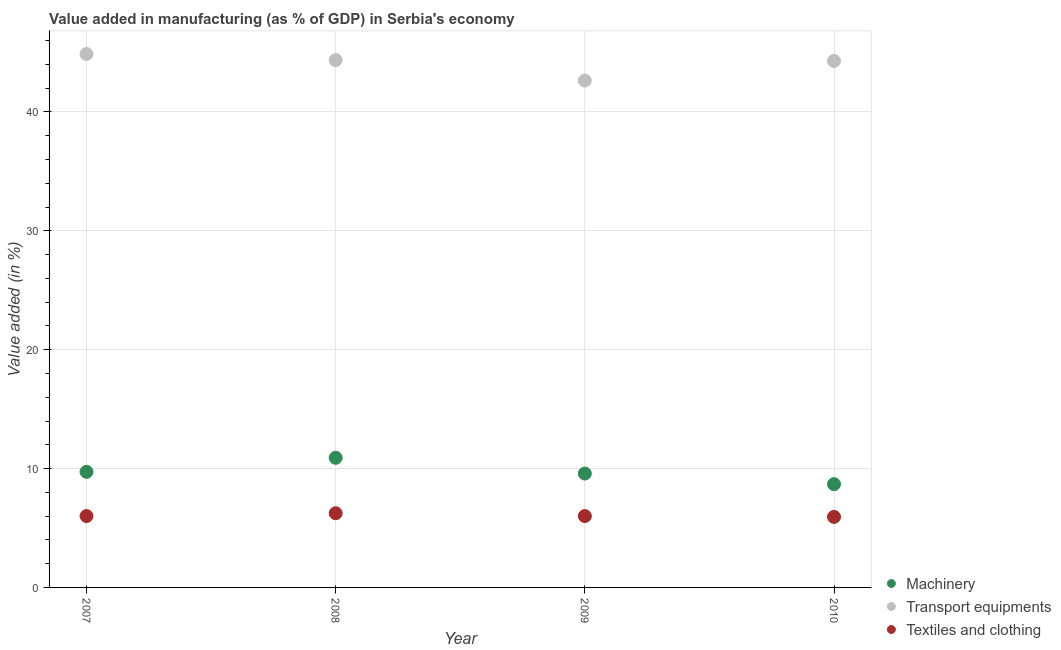How many different coloured dotlines are there?
Make the answer very short. 3. What is the value added in manufacturing machinery in 2010?
Your response must be concise. 8.69. Across all years, what is the maximum value added in manufacturing textile and clothing?
Your response must be concise. 6.24. Across all years, what is the minimum value added in manufacturing textile and clothing?
Ensure brevity in your answer.  5.94. In which year was the value added in manufacturing machinery maximum?
Ensure brevity in your answer.  2008. What is the total value added in manufacturing textile and clothing in the graph?
Your response must be concise. 24.19. What is the difference between the value added in manufacturing machinery in 2008 and that in 2009?
Your answer should be very brief. 1.33. What is the difference between the value added in manufacturing machinery in 2007 and the value added in manufacturing transport equipments in 2010?
Keep it short and to the point. -34.57. What is the average value added in manufacturing textile and clothing per year?
Ensure brevity in your answer.  6.05. In the year 2010, what is the difference between the value added in manufacturing transport equipments and value added in manufacturing machinery?
Your answer should be very brief. 35.61. In how many years, is the value added in manufacturing textile and clothing greater than 44 %?
Provide a succinct answer. 0. What is the ratio of the value added in manufacturing machinery in 2007 to that in 2009?
Ensure brevity in your answer.  1.02. Is the value added in manufacturing textile and clothing in 2007 less than that in 2008?
Ensure brevity in your answer.  Yes. Is the difference between the value added in manufacturing machinery in 2008 and 2010 greater than the difference between the value added in manufacturing textile and clothing in 2008 and 2010?
Offer a terse response. Yes. What is the difference between the highest and the second highest value added in manufacturing textile and clothing?
Offer a terse response. 0.24. What is the difference between the highest and the lowest value added in manufacturing textile and clothing?
Your response must be concise. 0.31. Is the sum of the value added in manufacturing machinery in 2007 and 2010 greater than the maximum value added in manufacturing textile and clothing across all years?
Your response must be concise. Yes. Does the value added in manufacturing transport equipments monotonically increase over the years?
Offer a very short reply. No. How many years are there in the graph?
Give a very brief answer. 4. What is the difference between two consecutive major ticks on the Y-axis?
Offer a terse response. 10. Are the values on the major ticks of Y-axis written in scientific E-notation?
Your answer should be compact. No. Does the graph contain any zero values?
Provide a succinct answer. No. Does the graph contain grids?
Your response must be concise. Yes. Where does the legend appear in the graph?
Ensure brevity in your answer.  Bottom right. What is the title of the graph?
Your response must be concise. Value added in manufacturing (as % of GDP) in Serbia's economy. What is the label or title of the X-axis?
Offer a terse response. Year. What is the label or title of the Y-axis?
Your response must be concise. Value added (in %). What is the Value added (in %) in Machinery in 2007?
Provide a succinct answer. 9.72. What is the Value added (in %) in Transport equipments in 2007?
Offer a very short reply. 44.88. What is the Value added (in %) of Textiles and clothing in 2007?
Ensure brevity in your answer.  6.01. What is the Value added (in %) in Machinery in 2008?
Make the answer very short. 10.91. What is the Value added (in %) in Transport equipments in 2008?
Your answer should be compact. 44.37. What is the Value added (in %) of Textiles and clothing in 2008?
Keep it short and to the point. 6.24. What is the Value added (in %) of Machinery in 2009?
Offer a very short reply. 9.58. What is the Value added (in %) in Transport equipments in 2009?
Your answer should be compact. 42.64. What is the Value added (in %) in Textiles and clothing in 2009?
Provide a short and direct response. 6. What is the Value added (in %) of Machinery in 2010?
Give a very brief answer. 8.69. What is the Value added (in %) in Transport equipments in 2010?
Provide a succinct answer. 44.29. What is the Value added (in %) of Textiles and clothing in 2010?
Offer a very short reply. 5.94. Across all years, what is the maximum Value added (in %) of Machinery?
Ensure brevity in your answer.  10.91. Across all years, what is the maximum Value added (in %) of Transport equipments?
Make the answer very short. 44.88. Across all years, what is the maximum Value added (in %) of Textiles and clothing?
Keep it short and to the point. 6.24. Across all years, what is the minimum Value added (in %) of Machinery?
Your answer should be very brief. 8.69. Across all years, what is the minimum Value added (in %) in Transport equipments?
Keep it short and to the point. 42.64. Across all years, what is the minimum Value added (in %) in Textiles and clothing?
Ensure brevity in your answer.  5.94. What is the total Value added (in %) of Machinery in the graph?
Your answer should be compact. 38.9. What is the total Value added (in %) in Transport equipments in the graph?
Provide a succinct answer. 176.18. What is the total Value added (in %) of Textiles and clothing in the graph?
Provide a succinct answer. 24.19. What is the difference between the Value added (in %) of Machinery in 2007 and that in 2008?
Give a very brief answer. -1.18. What is the difference between the Value added (in %) in Transport equipments in 2007 and that in 2008?
Offer a very short reply. 0.51. What is the difference between the Value added (in %) of Textiles and clothing in 2007 and that in 2008?
Give a very brief answer. -0.24. What is the difference between the Value added (in %) in Machinery in 2007 and that in 2009?
Offer a terse response. 0.14. What is the difference between the Value added (in %) in Transport equipments in 2007 and that in 2009?
Ensure brevity in your answer.  2.24. What is the difference between the Value added (in %) in Textiles and clothing in 2007 and that in 2009?
Provide a succinct answer. 0. What is the difference between the Value added (in %) in Machinery in 2007 and that in 2010?
Make the answer very short. 1.04. What is the difference between the Value added (in %) of Transport equipments in 2007 and that in 2010?
Keep it short and to the point. 0.59. What is the difference between the Value added (in %) of Textiles and clothing in 2007 and that in 2010?
Make the answer very short. 0.07. What is the difference between the Value added (in %) in Machinery in 2008 and that in 2009?
Provide a short and direct response. 1.33. What is the difference between the Value added (in %) of Transport equipments in 2008 and that in 2009?
Give a very brief answer. 1.73. What is the difference between the Value added (in %) of Textiles and clothing in 2008 and that in 2009?
Provide a succinct answer. 0.24. What is the difference between the Value added (in %) in Machinery in 2008 and that in 2010?
Make the answer very short. 2.22. What is the difference between the Value added (in %) in Transport equipments in 2008 and that in 2010?
Offer a very short reply. 0.07. What is the difference between the Value added (in %) in Textiles and clothing in 2008 and that in 2010?
Your answer should be very brief. 0.31. What is the difference between the Value added (in %) in Machinery in 2009 and that in 2010?
Provide a succinct answer. 0.89. What is the difference between the Value added (in %) of Transport equipments in 2009 and that in 2010?
Give a very brief answer. -1.66. What is the difference between the Value added (in %) in Textiles and clothing in 2009 and that in 2010?
Your answer should be very brief. 0.07. What is the difference between the Value added (in %) in Machinery in 2007 and the Value added (in %) in Transport equipments in 2008?
Keep it short and to the point. -34.64. What is the difference between the Value added (in %) in Machinery in 2007 and the Value added (in %) in Textiles and clothing in 2008?
Your response must be concise. 3.48. What is the difference between the Value added (in %) of Transport equipments in 2007 and the Value added (in %) of Textiles and clothing in 2008?
Your answer should be compact. 38.64. What is the difference between the Value added (in %) of Machinery in 2007 and the Value added (in %) of Transport equipments in 2009?
Your answer should be compact. -32.92. What is the difference between the Value added (in %) in Machinery in 2007 and the Value added (in %) in Textiles and clothing in 2009?
Provide a short and direct response. 3.72. What is the difference between the Value added (in %) of Transport equipments in 2007 and the Value added (in %) of Textiles and clothing in 2009?
Make the answer very short. 38.88. What is the difference between the Value added (in %) in Machinery in 2007 and the Value added (in %) in Transport equipments in 2010?
Give a very brief answer. -34.57. What is the difference between the Value added (in %) of Machinery in 2007 and the Value added (in %) of Textiles and clothing in 2010?
Keep it short and to the point. 3.79. What is the difference between the Value added (in %) of Transport equipments in 2007 and the Value added (in %) of Textiles and clothing in 2010?
Give a very brief answer. 38.94. What is the difference between the Value added (in %) in Machinery in 2008 and the Value added (in %) in Transport equipments in 2009?
Provide a succinct answer. -31.73. What is the difference between the Value added (in %) of Machinery in 2008 and the Value added (in %) of Textiles and clothing in 2009?
Ensure brevity in your answer.  4.9. What is the difference between the Value added (in %) of Transport equipments in 2008 and the Value added (in %) of Textiles and clothing in 2009?
Your response must be concise. 38.36. What is the difference between the Value added (in %) of Machinery in 2008 and the Value added (in %) of Transport equipments in 2010?
Offer a very short reply. -33.39. What is the difference between the Value added (in %) of Machinery in 2008 and the Value added (in %) of Textiles and clothing in 2010?
Provide a short and direct response. 4.97. What is the difference between the Value added (in %) in Transport equipments in 2008 and the Value added (in %) in Textiles and clothing in 2010?
Your answer should be compact. 38.43. What is the difference between the Value added (in %) of Machinery in 2009 and the Value added (in %) of Transport equipments in 2010?
Offer a terse response. -34.71. What is the difference between the Value added (in %) of Machinery in 2009 and the Value added (in %) of Textiles and clothing in 2010?
Offer a very short reply. 3.64. What is the difference between the Value added (in %) of Transport equipments in 2009 and the Value added (in %) of Textiles and clothing in 2010?
Offer a very short reply. 36.7. What is the average Value added (in %) of Machinery per year?
Ensure brevity in your answer.  9.72. What is the average Value added (in %) of Transport equipments per year?
Provide a succinct answer. 44.04. What is the average Value added (in %) of Textiles and clothing per year?
Your answer should be very brief. 6.05. In the year 2007, what is the difference between the Value added (in %) of Machinery and Value added (in %) of Transport equipments?
Provide a short and direct response. -35.16. In the year 2007, what is the difference between the Value added (in %) of Machinery and Value added (in %) of Textiles and clothing?
Provide a short and direct response. 3.72. In the year 2007, what is the difference between the Value added (in %) in Transport equipments and Value added (in %) in Textiles and clothing?
Your answer should be very brief. 38.87. In the year 2008, what is the difference between the Value added (in %) in Machinery and Value added (in %) in Transport equipments?
Make the answer very short. -33.46. In the year 2008, what is the difference between the Value added (in %) of Machinery and Value added (in %) of Textiles and clothing?
Give a very brief answer. 4.66. In the year 2008, what is the difference between the Value added (in %) in Transport equipments and Value added (in %) in Textiles and clothing?
Offer a very short reply. 38.12. In the year 2009, what is the difference between the Value added (in %) of Machinery and Value added (in %) of Transport equipments?
Ensure brevity in your answer.  -33.06. In the year 2009, what is the difference between the Value added (in %) in Machinery and Value added (in %) in Textiles and clothing?
Keep it short and to the point. 3.58. In the year 2009, what is the difference between the Value added (in %) of Transport equipments and Value added (in %) of Textiles and clothing?
Your answer should be very brief. 36.64. In the year 2010, what is the difference between the Value added (in %) in Machinery and Value added (in %) in Transport equipments?
Your answer should be compact. -35.61. In the year 2010, what is the difference between the Value added (in %) in Machinery and Value added (in %) in Textiles and clothing?
Ensure brevity in your answer.  2.75. In the year 2010, what is the difference between the Value added (in %) in Transport equipments and Value added (in %) in Textiles and clothing?
Your answer should be compact. 38.36. What is the ratio of the Value added (in %) in Machinery in 2007 to that in 2008?
Offer a terse response. 0.89. What is the ratio of the Value added (in %) in Transport equipments in 2007 to that in 2008?
Provide a succinct answer. 1.01. What is the ratio of the Value added (in %) in Textiles and clothing in 2007 to that in 2008?
Your response must be concise. 0.96. What is the ratio of the Value added (in %) in Machinery in 2007 to that in 2009?
Keep it short and to the point. 1.01. What is the ratio of the Value added (in %) in Transport equipments in 2007 to that in 2009?
Give a very brief answer. 1.05. What is the ratio of the Value added (in %) in Textiles and clothing in 2007 to that in 2009?
Provide a short and direct response. 1. What is the ratio of the Value added (in %) in Machinery in 2007 to that in 2010?
Keep it short and to the point. 1.12. What is the ratio of the Value added (in %) in Transport equipments in 2007 to that in 2010?
Offer a very short reply. 1.01. What is the ratio of the Value added (in %) in Textiles and clothing in 2007 to that in 2010?
Give a very brief answer. 1.01. What is the ratio of the Value added (in %) of Machinery in 2008 to that in 2009?
Your answer should be very brief. 1.14. What is the ratio of the Value added (in %) of Transport equipments in 2008 to that in 2009?
Keep it short and to the point. 1.04. What is the ratio of the Value added (in %) of Textiles and clothing in 2008 to that in 2009?
Give a very brief answer. 1.04. What is the ratio of the Value added (in %) in Machinery in 2008 to that in 2010?
Your response must be concise. 1.26. What is the ratio of the Value added (in %) in Transport equipments in 2008 to that in 2010?
Provide a succinct answer. 1. What is the ratio of the Value added (in %) of Textiles and clothing in 2008 to that in 2010?
Keep it short and to the point. 1.05. What is the ratio of the Value added (in %) of Machinery in 2009 to that in 2010?
Keep it short and to the point. 1.1. What is the ratio of the Value added (in %) in Transport equipments in 2009 to that in 2010?
Your answer should be compact. 0.96. What is the ratio of the Value added (in %) of Textiles and clothing in 2009 to that in 2010?
Provide a succinct answer. 1.01. What is the difference between the highest and the second highest Value added (in %) of Machinery?
Your response must be concise. 1.18. What is the difference between the highest and the second highest Value added (in %) of Transport equipments?
Provide a succinct answer. 0.51. What is the difference between the highest and the second highest Value added (in %) in Textiles and clothing?
Make the answer very short. 0.24. What is the difference between the highest and the lowest Value added (in %) of Machinery?
Provide a succinct answer. 2.22. What is the difference between the highest and the lowest Value added (in %) of Transport equipments?
Provide a succinct answer. 2.24. What is the difference between the highest and the lowest Value added (in %) of Textiles and clothing?
Give a very brief answer. 0.31. 